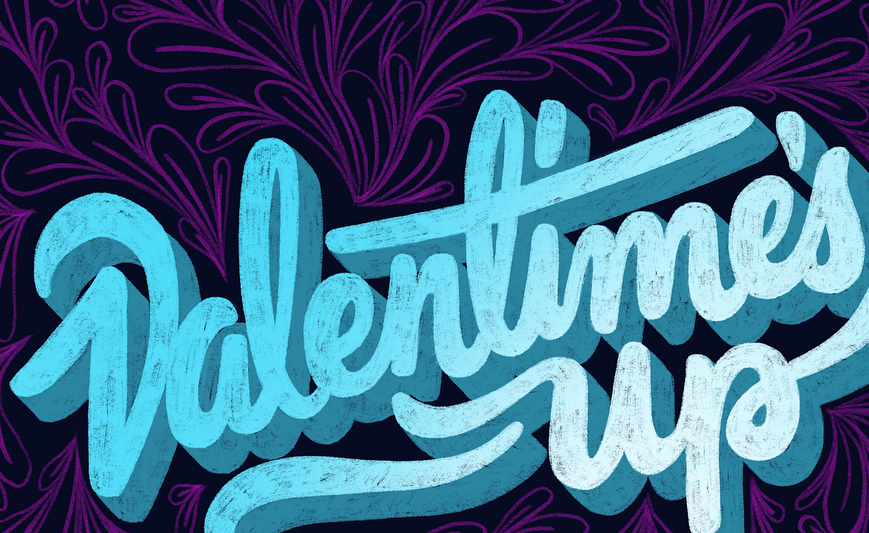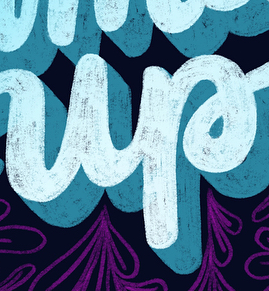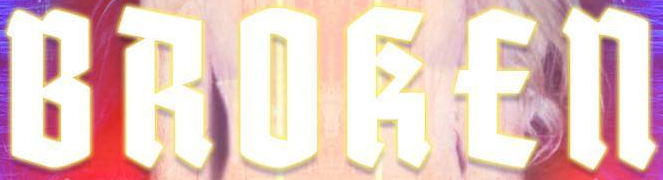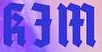Read the text content from these images in order, separated by a semicolon. Valentime's; up; BROKEn; kƎm 